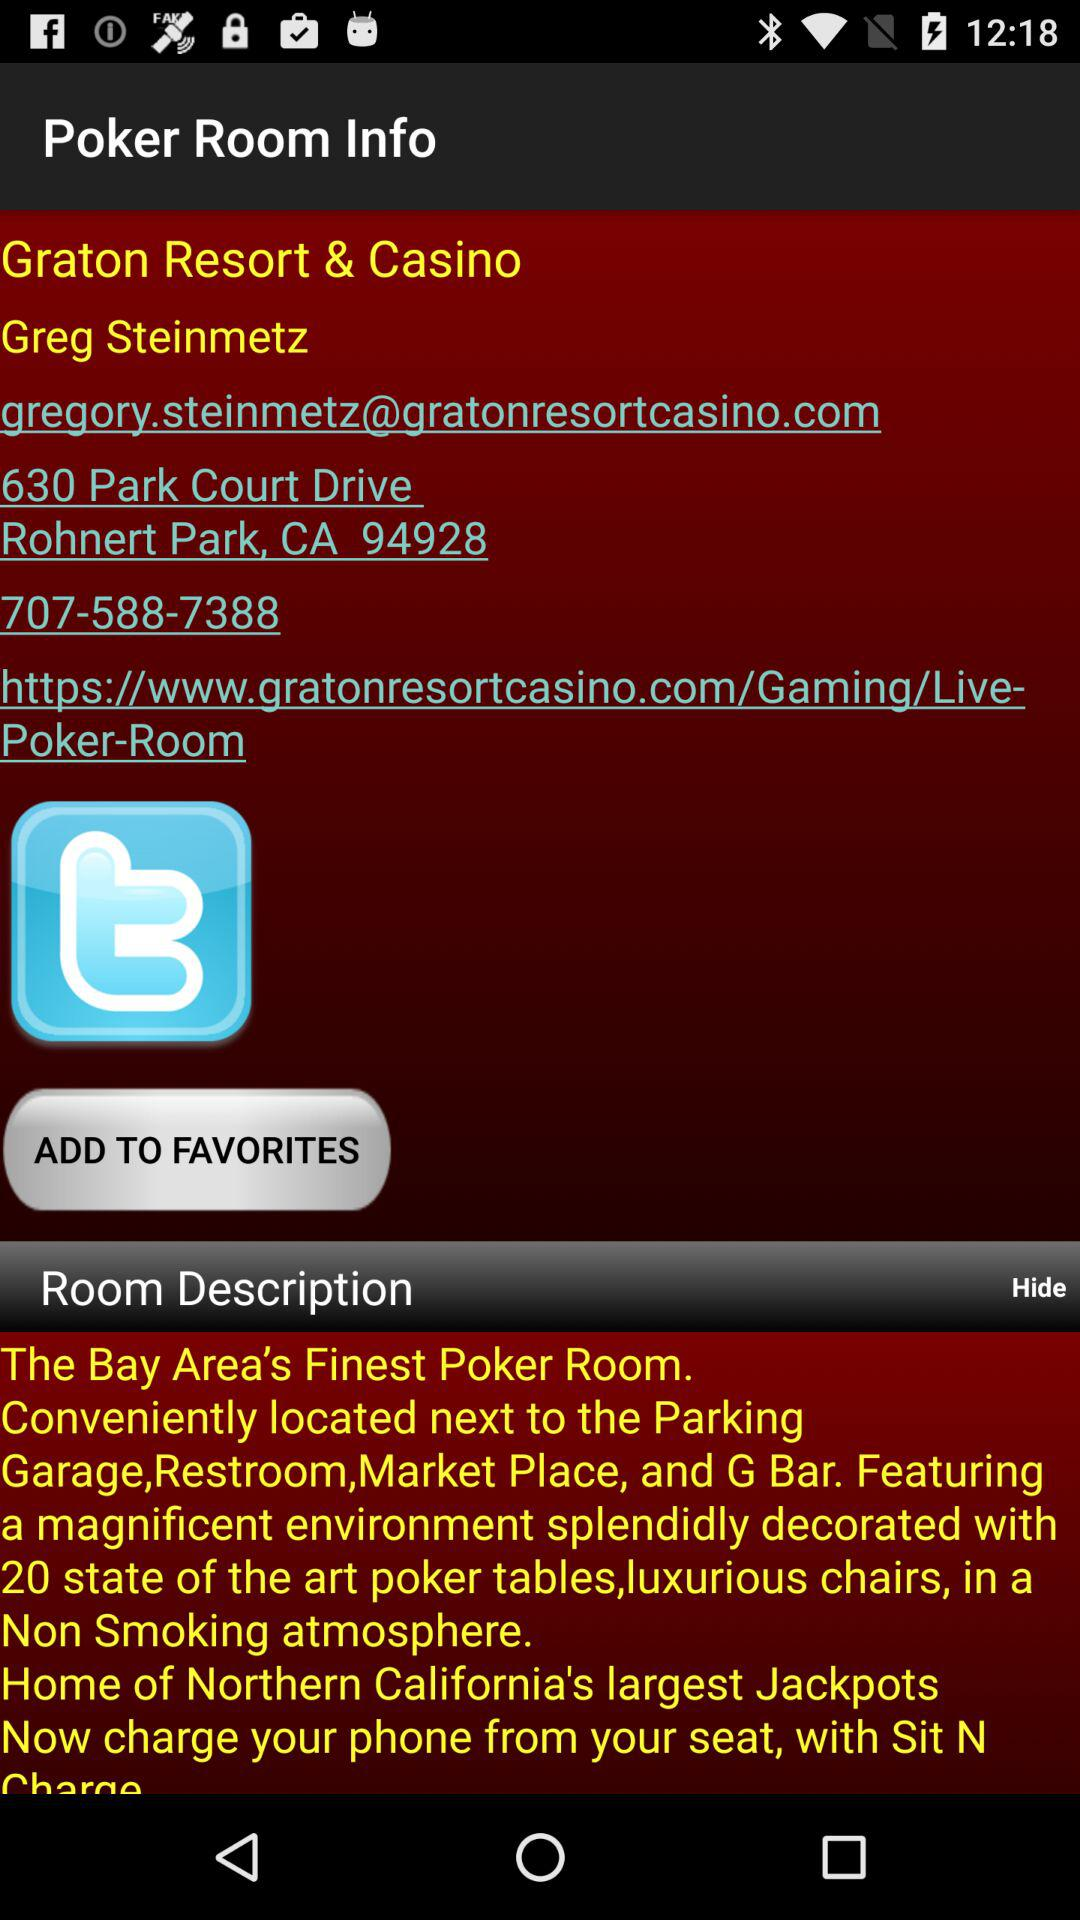Which is the finest Poker room in the Graton Resort and Casino?
When the provided information is insufficient, respond with <no answer>. <no answer> 